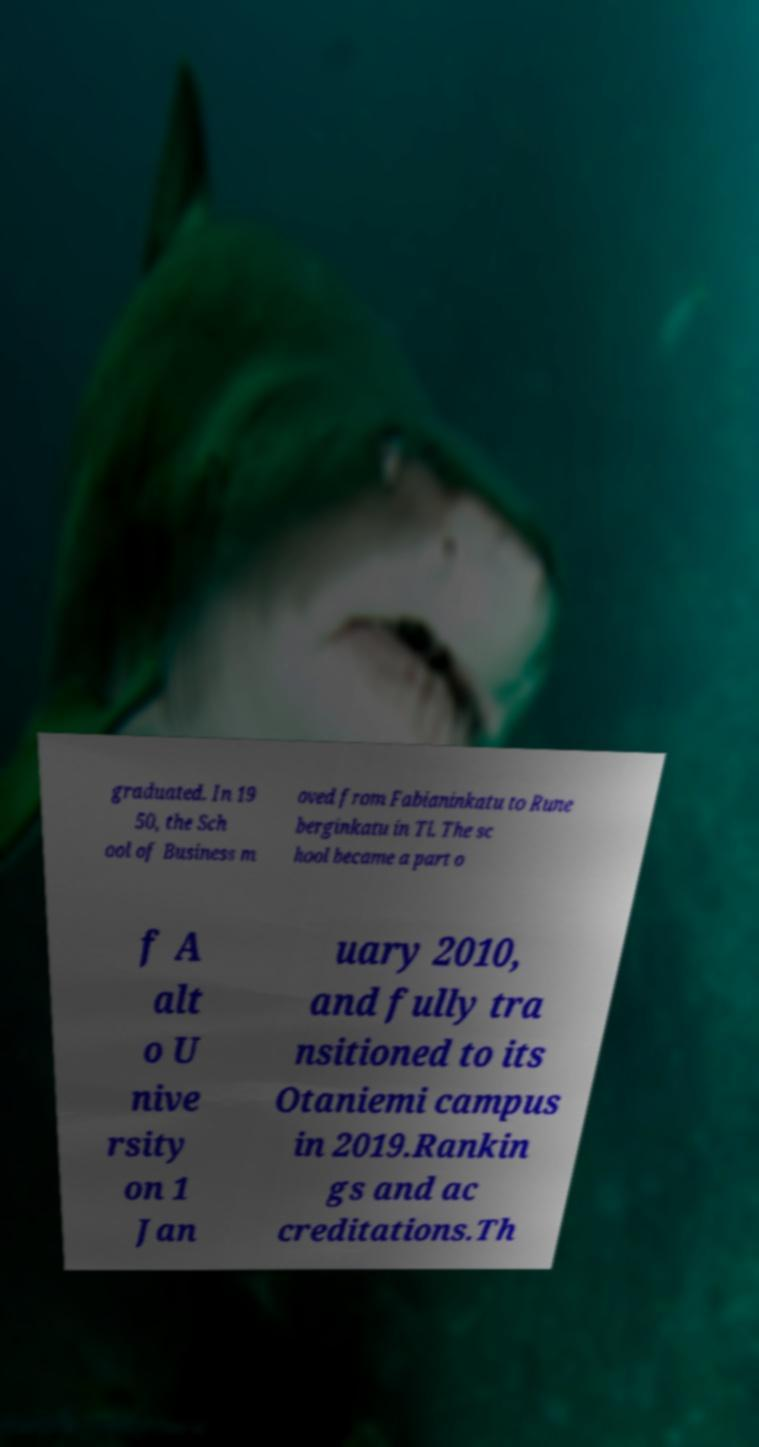There's text embedded in this image that I need extracted. Can you transcribe it verbatim? graduated. In 19 50, the Sch ool of Business m oved from Fabianinkatu to Rune berginkatu in Tl. The sc hool became a part o f A alt o U nive rsity on 1 Jan uary 2010, and fully tra nsitioned to its Otaniemi campus in 2019.Rankin gs and ac creditations.Th 